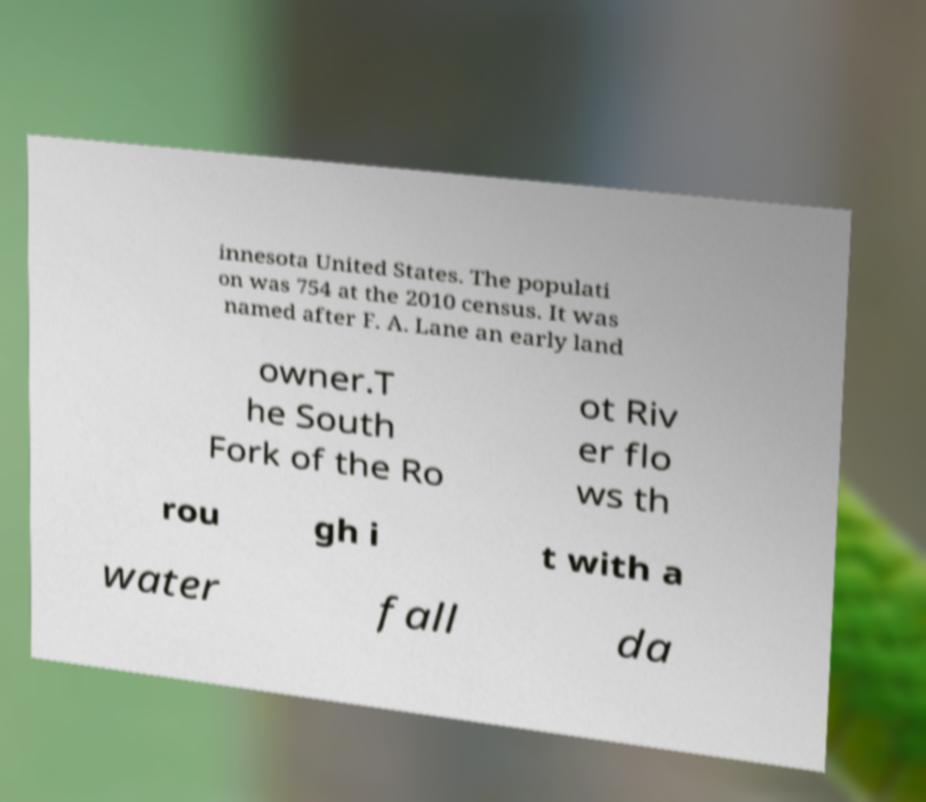Could you extract and type out the text from this image? innesota United States. The populati on was 754 at the 2010 census. It was named after F. A. Lane an early land owner.T he South Fork of the Ro ot Riv er flo ws th rou gh i t with a water fall da 